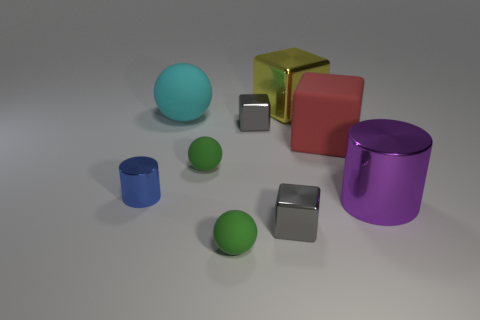There is another rubber thing that is the same shape as the yellow object; what is its size?
Offer a very short reply. Large. There is a thing right of the big red thing; is its shape the same as the tiny blue metallic thing?
Offer a terse response. Yes. What is the color of the matte block behind the big cylinder?
Offer a very short reply. Red. How many other objects are there of the same size as the yellow metal cube?
Your response must be concise. 3. Are there any other things that are the same shape as the big cyan rubber thing?
Keep it short and to the point. Yes. Are there an equal number of large purple objects that are on the right side of the blue metal object and cyan matte things?
Your response must be concise. Yes. How many big blocks are the same material as the large purple object?
Provide a short and direct response. 1. What color is the other large thing that is made of the same material as the cyan object?
Offer a very short reply. Red. Is the red thing the same shape as the blue metal object?
Your answer should be very brief. No. Are there any balls in front of the tiny gray object in front of the gray shiny block behind the big red matte cube?
Your response must be concise. Yes. 